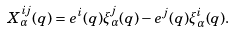Convert formula to latex. <formula><loc_0><loc_0><loc_500><loc_500>X ^ { i j } _ { \alpha } ( q ) = e ^ { i } ( q ) \xi ^ { j } _ { \alpha } ( q ) - e ^ { j } ( q ) \xi ^ { i } _ { \alpha } ( q ) .</formula> 